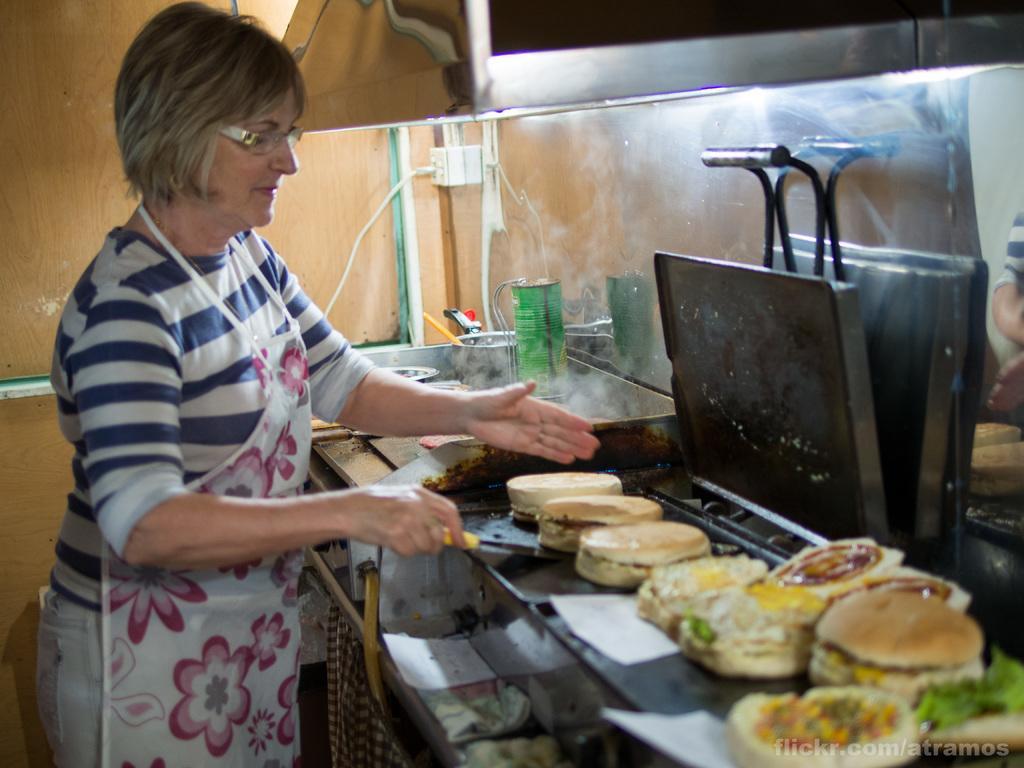Please provide a concise description of this image. In this image, we can see a woman is wearing an apron and holding a spatula. Here we can see some food. Background we can see few objects and socket on the wall. 